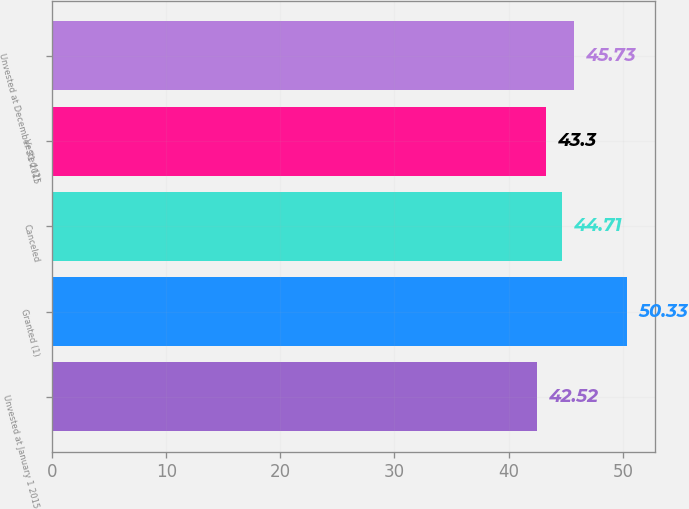<chart> <loc_0><loc_0><loc_500><loc_500><bar_chart><fcel>Unvested at January 1 2015<fcel>Granted (1)<fcel>Canceled<fcel>Vested (2)<fcel>Unvested at December 31 2015<nl><fcel>42.52<fcel>50.33<fcel>44.71<fcel>43.3<fcel>45.73<nl></chart> 